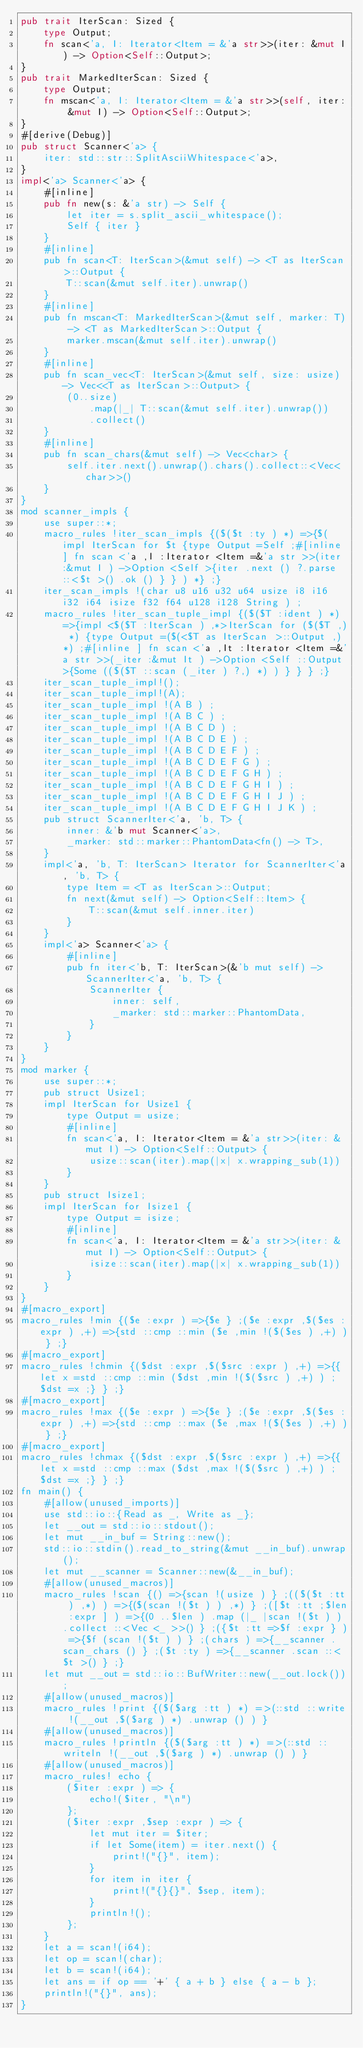Convert code to text. <code><loc_0><loc_0><loc_500><loc_500><_Rust_>pub trait IterScan: Sized {
    type Output;
    fn scan<'a, I: Iterator<Item = &'a str>>(iter: &mut I) -> Option<Self::Output>;
}
pub trait MarkedIterScan: Sized {
    type Output;
    fn mscan<'a, I: Iterator<Item = &'a str>>(self, iter: &mut I) -> Option<Self::Output>;
}
#[derive(Debug)]
pub struct Scanner<'a> {
    iter: std::str::SplitAsciiWhitespace<'a>,
}
impl<'a> Scanner<'a> {
    #[inline]
    pub fn new(s: &'a str) -> Self {
        let iter = s.split_ascii_whitespace();
        Self { iter }
    }
    #[inline]
    pub fn scan<T: IterScan>(&mut self) -> <T as IterScan>::Output {
        T::scan(&mut self.iter).unwrap()
    }
    #[inline]
    pub fn mscan<T: MarkedIterScan>(&mut self, marker: T) -> <T as MarkedIterScan>::Output {
        marker.mscan(&mut self.iter).unwrap()
    }
    #[inline]
    pub fn scan_vec<T: IterScan>(&mut self, size: usize) -> Vec<<T as IterScan>::Output> {
        (0..size)
            .map(|_| T::scan(&mut self.iter).unwrap())
            .collect()
    }
    #[inline]
    pub fn scan_chars(&mut self) -> Vec<char> {
        self.iter.next().unwrap().chars().collect::<Vec<char>>()
    }
}
mod scanner_impls {
    use super::*;
    macro_rules !iter_scan_impls {($($t :ty ) *) =>{$(impl IterScan for $t {type Output =Self ;#[inline ] fn scan <'a ,I :Iterator <Item =&'a str >>(iter :&mut I ) ->Option <Self >{iter .next () ?.parse ::<$t >() .ok () } } ) *} ;}
    iter_scan_impls !(char u8 u16 u32 u64 usize i8 i16 i32 i64 isize f32 f64 u128 i128 String ) ;
    macro_rules !iter_scan_tuple_impl {($($T :ident ) *) =>{impl <$($T :IterScan ) ,*>IterScan for ($($T ,) *) {type Output =($(<$T as IterScan >::Output ,) *) ;#[inline ] fn scan <'a ,It :Iterator <Item =&'a str >>(_iter :&mut It ) ->Option <Self ::Output >{Some (($($T ::scan (_iter ) ?,) *) ) } } } ;}
    iter_scan_tuple_impl!();
    iter_scan_tuple_impl!(A);
    iter_scan_tuple_impl !(A B ) ;
    iter_scan_tuple_impl !(A B C ) ;
    iter_scan_tuple_impl !(A B C D ) ;
    iter_scan_tuple_impl !(A B C D E ) ;
    iter_scan_tuple_impl !(A B C D E F ) ;
    iter_scan_tuple_impl !(A B C D E F G ) ;
    iter_scan_tuple_impl !(A B C D E F G H ) ;
    iter_scan_tuple_impl !(A B C D E F G H I ) ;
    iter_scan_tuple_impl !(A B C D E F G H I J ) ;
    iter_scan_tuple_impl !(A B C D E F G H I J K ) ;
    pub struct ScannerIter<'a, 'b, T> {
        inner: &'b mut Scanner<'a>,
        _marker: std::marker::PhantomData<fn() -> T>,
    }
    impl<'a, 'b, T: IterScan> Iterator for ScannerIter<'a, 'b, T> {
        type Item = <T as IterScan>::Output;
        fn next(&mut self) -> Option<Self::Item> {
            T::scan(&mut self.inner.iter)
        }
    }
    impl<'a> Scanner<'a> {
        #[inline]
        pub fn iter<'b, T: IterScan>(&'b mut self) -> ScannerIter<'a, 'b, T> {
            ScannerIter {
                inner: self,
                _marker: std::marker::PhantomData,
            }
        }
    }
}
mod marker {
    use super::*;
    pub struct Usize1;
    impl IterScan for Usize1 {
        type Output = usize;
        #[inline]
        fn scan<'a, I: Iterator<Item = &'a str>>(iter: &mut I) -> Option<Self::Output> {
            usize::scan(iter).map(|x| x.wrapping_sub(1))
        }
    }
    pub struct Isize1;
    impl IterScan for Isize1 {
        type Output = isize;
        #[inline]
        fn scan<'a, I: Iterator<Item = &'a str>>(iter: &mut I) -> Option<Self::Output> {
            isize::scan(iter).map(|x| x.wrapping_sub(1))
        }
    }
}
#[macro_export]
macro_rules !min {($e :expr ) =>{$e } ;($e :expr ,$($es :expr ) ,+) =>{std ::cmp ::min ($e ,min !($($es ) ,+) ) } ;}
#[macro_export]
macro_rules !chmin {($dst :expr ,$($src :expr ) ,+) =>{{let x =std ::cmp ::min ($dst ,min !($($src ) ,+) ) ;$dst =x ;} } ;}
#[macro_export]
macro_rules !max {($e :expr ) =>{$e } ;($e :expr ,$($es :expr ) ,+) =>{std ::cmp ::max ($e ,max !($($es ) ,+) ) } ;}
#[macro_export]
macro_rules !chmax {($dst :expr ,$($src :expr ) ,+) =>{{let x =std ::cmp ::max ($dst ,max !($($src ) ,+) ) ;$dst =x ;} } ;}
fn main() {
    #[allow(unused_imports)]
    use std::io::{Read as _, Write as _};
    let __out = std::io::stdout();
    let mut __in_buf = String::new();
    std::io::stdin().read_to_string(&mut __in_buf).unwrap();
    let mut __scanner = Scanner::new(&__in_buf);
    #[allow(unused_macros)]
    macro_rules !scan {() =>{scan !(usize ) } ;(($($t :tt ) ,*) ) =>{($(scan !($t ) ) ,*) } ;([$t :tt ;$len :expr ] ) =>{(0 ..$len ) .map (|_ |scan !($t ) ) .collect ::<Vec <_ >>() } ;({$t :tt =>$f :expr } ) =>{$f (scan !($t ) ) } ;(chars ) =>{__scanner .scan_chars () } ;($t :ty ) =>{__scanner .scan ::<$t >() } ;}
    let mut __out = std::io::BufWriter::new(__out.lock());
    #[allow(unused_macros)]
    macro_rules !print {($($arg :tt ) *) =>(::std ::write !(__out ,$($arg ) *) .unwrap () ) }
    #[allow(unused_macros)]
    macro_rules !println {($($arg :tt ) *) =>(::std ::writeln !(__out ,$($arg ) *) .unwrap () ) }
    #[allow(unused_macros)]
    macro_rules! echo {
        ($iter :expr ) => {
            echo!($iter, "\n")
        };
        ($iter :expr ,$sep :expr ) => {
            let mut iter = $iter;
            if let Some(item) = iter.next() {
                print!("{}", item);
            }
            for item in iter {
                print!("{}{}", $sep, item);
            }
            println!();
        };
    }
    let a = scan!(i64);
    let op = scan!(char);
    let b = scan!(i64);
    let ans = if op == '+' { a + b } else { a - b };
    println!("{}", ans);
}</code> 